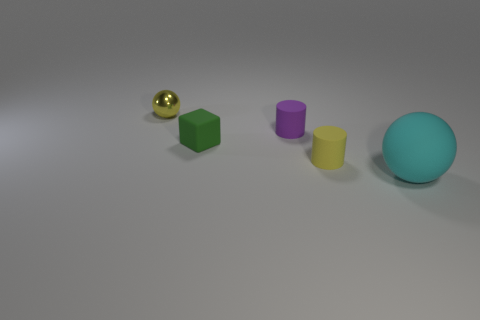Do the yellow object behind the rubber cube and the green matte thing have the same size?
Your answer should be very brief. Yes. Is there a matte ball that is in front of the cylinder on the left side of the tiny yellow thing right of the tiny metallic sphere?
Offer a very short reply. Yes. What number of metal things are either small yellow cylinders or purple things?
Offer a very short reply. 0. How many other things are the same shape as the tiny yellow matte thing?
Your answer should be compact. 1. Is the number of large metallic cylinders greater than the number of purple rubber objects?
Your answer should be very brief. No. What size is the cyan thing that is right of the sphere that is behind the ball that is in front of the tiny yellow sphere?
Make the answer very short. Large. There is a sphere that is on the left side of the green thing; what size is it?
Ensure brevity in your answer.  Small. How many things are small metallic objects or matte objects that are on the right side of the tiny purple cylinder?
Your answer should be compact. 3. What number of other objects are the same size as the cyan sphere?
Your response must be concise. 0. What is the material of the other small object that is the same shape as the purple object?
Your answer should be compact. Rubber. 